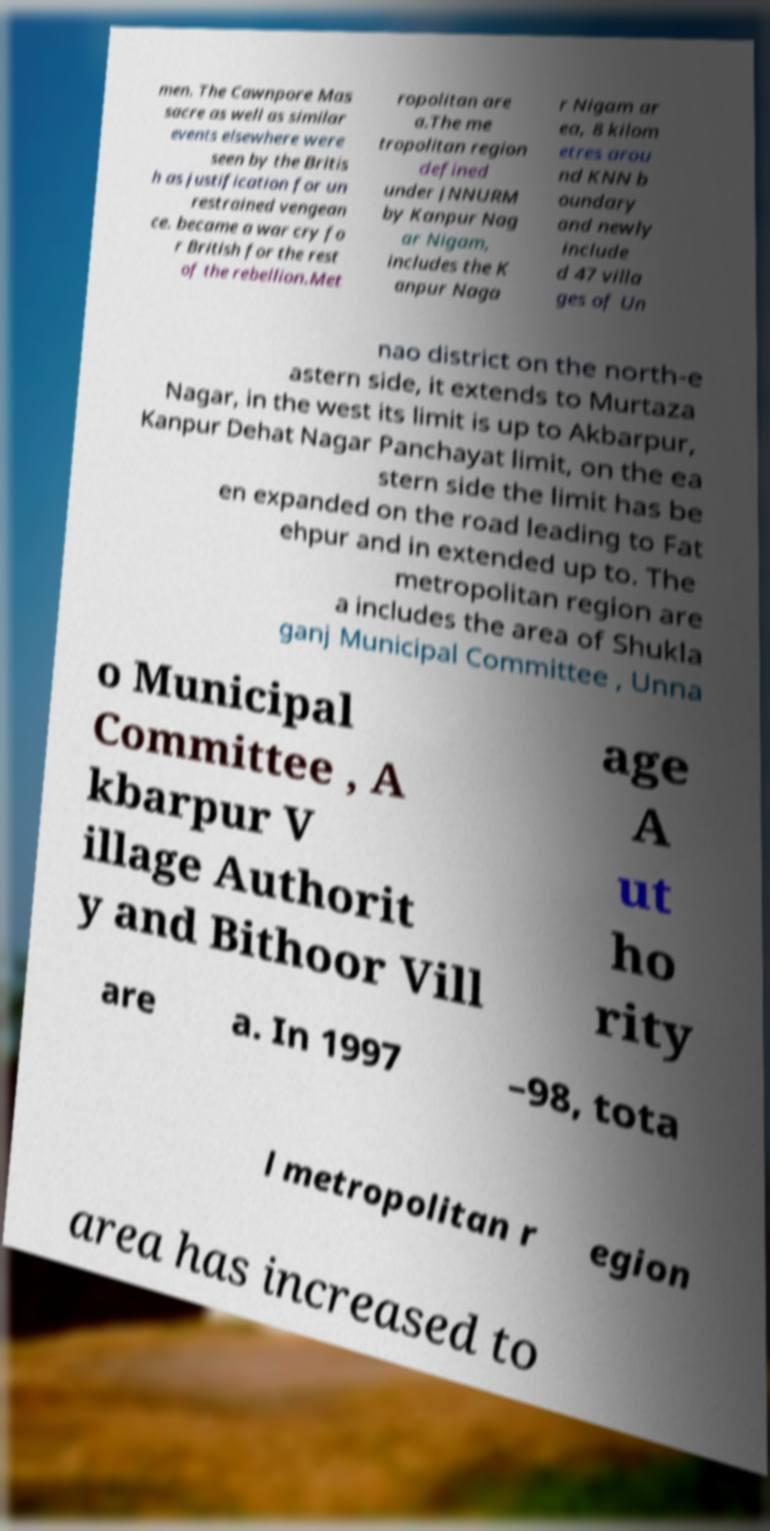What messages or text are displayed in this image? I need them in a readable, typed format. men. The Cawnpore Mas sacre as well as similar events elsewhere were seen by the Britis h as justification for un restrained vengean ce. became a war cry fo r British for the rest of the rebellion.Met ropolitan are a.The me tropolitan region defined under JNNURM by Kanpur Nag ar Nigam, includes the K anpur Naga r Nigam ar ea, 8 kilom etres arou nd KNN b oundary and newly include d 47 villa ges of Un nao district on the north-e astern side, it extends to Murtaza Nagar, in the west its limit is up to Akbarpur, Kanpur Dehat Nagar Panchayat limit, on the ea stern side the limit has be en expanded on the road leading to Fat ehpur and in extended up to. The metropolitan region are a includes the area of Shukla ganj Municipal Committee , Unna o Municipal Committee , A kbarpur V illage Authorit y and Bithoor Vill age A ut ho rity are a. In 1997 –98, tota l metropolitan r egion area has increased to 